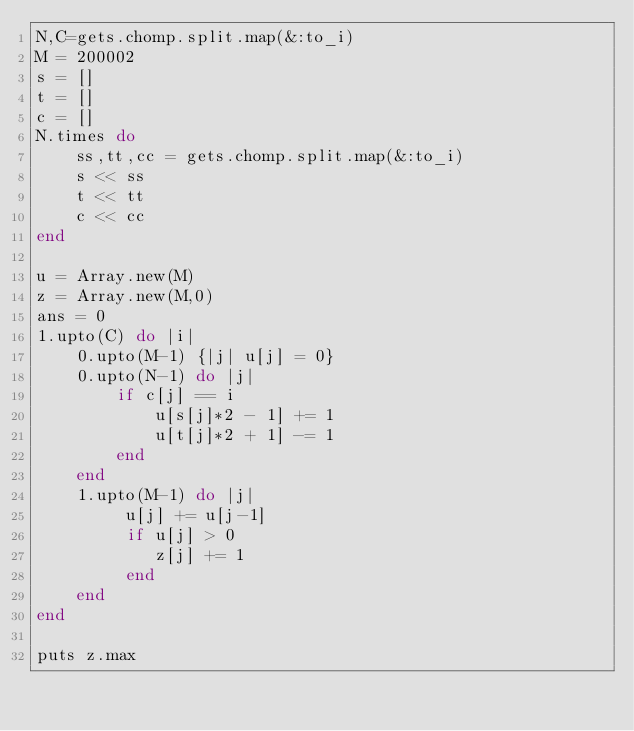<code> <loc_0><loc_0><loc_500><loc_500><_Ruby_>N,C=gets.chomp.split.map(&:to_i)
M = 200002
s = []
t = []
c = []
N.times do
    ss,tt,cc = gets.chomp.split.map(&:to_i)    
    s << ss
    t << tt
    c << cc
end

u = Array.new(M)
z = Array.new(M,0)
ans = 0
1.upto(C) do |i|
    0.upto(M-1) {|j| u[j] = 0}
    0.upto(N-1) do |j|
        if c[j] == i
            u[s[j]*2 - 1] += 1
            u[t[j]*2 + 1] -= 1
        end
    end
    1.upto(M-1) do |j|
         u[j] += u[j-1]
         if u[j] > 0
            z[j] += 1
         end
    end
end

puts z.max
</code> 